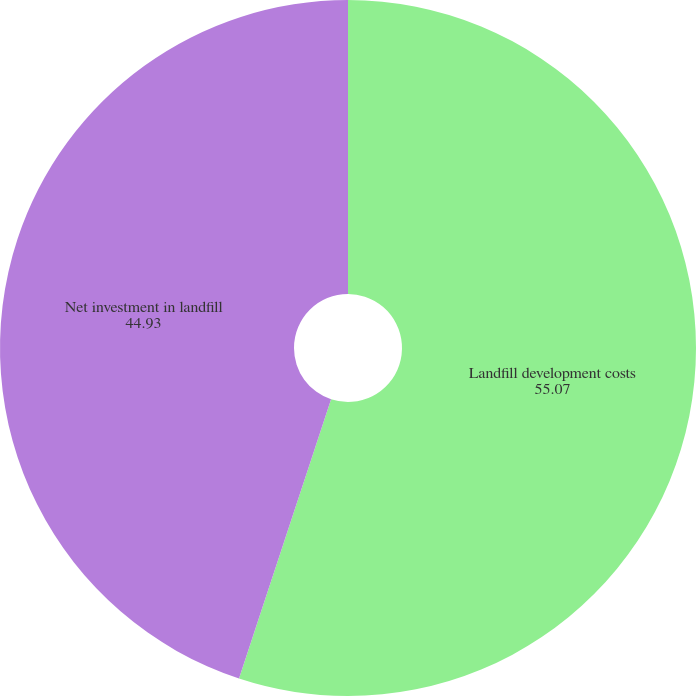<chart> <loc_0><loc_0><loc_500><loc_500><pie_chart><fcel>Landfill development costs<fcel>Net investment in landfill<nl><fcel>55.07%<fcel>44.93%<nl></chart> 